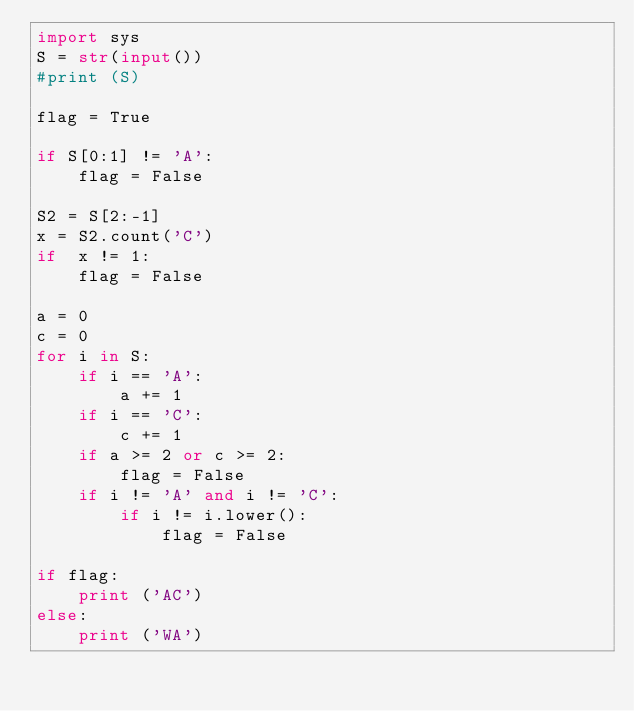Convert code to text. <code><loc_0><loc_0><loc_500><loc_500><_Python_>import sys
S = str(input())
#print (S)

flag = True

if S[0:1] != 'A':
    flag = False

S2 = S[2:-1]
x = S2.count('C')
if  x != 1:
    flag = False

a = 0
c = 0
for i in S:
    if i == 'A':
        a += 1
    if i == 'C':
        c += 1
    if a >= 2 or c >= 2:
        flag = False
    if i != 'A' and i != 'C':
        if i != i.lower():
            flag = False

if flag:
    print ('AC')
else:
    print ('WA')</code> 